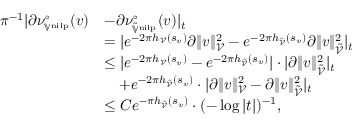Convert formula to latex. <formula><loc_0><loc_0><loc_500><loc_500>\begin{array} { r l } { \pi ^ { - 1 } | \partial \nu _ { \mathbb { V } ^ { n i l p } } ^ { \circ } ( v ) } & { - \partial \nu _ { \tilde { \mathbb { V } } ^ { n i l p } } ^ { \circ } ( v ) | _ { t } } \\ & { = | e ^ { - 2 \pi h _ { \mathcal { V } } ( s _ { v } ) } \partial \| v \| _ { \mathcal { V } } ^ { 2 } - e ^ { - 2 \pi h _ { \tilde { \mathcal { V } } } ( s _ { v } ) } \partial \| v \| _ { \tilde { \mathcal { V } } } ^ { 2 } | _ { t } } \\ & { \leq | e ^ { - 2 \pi h _ { \mathcal { V } } ( s _ { v } ) } - e ^ { - 2 \pi h _ { \tilde { \mathcal { V } } } ( s _ { v } ) } | \cdot | \partial \| v \| _ { \tilde { \mathcal { V } } } ^ { 2 } | _ { t } } \\ & { \quad + e ^ { - 2 \pi h _ { \tilde { \mathcal { V } } } ( s _ { v } ) } \cdot | \partial \| v \| _ { \mathcal { V } } ^ { 2 } - \partial \| v \| _ { \tilde { \mathcal { V } } } ^ { 2 } | _ { t } } \\ & { \leq C e ^ { - \pi h _ { \tilde { \mathcal { V } } } ( s _ { v } ) } \cdot ( - \log | t | ) ^ { - 1 } , } \end{array}</formula> 